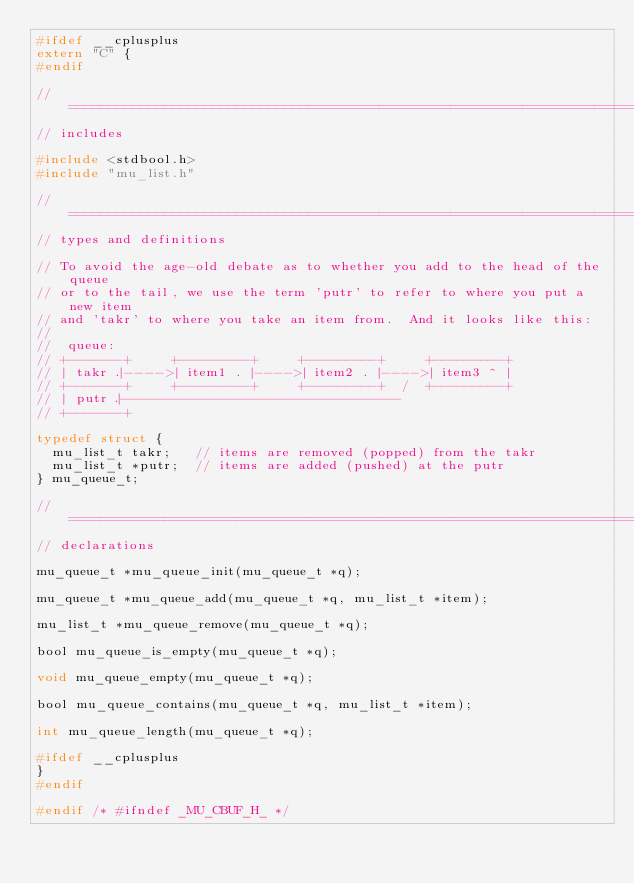Convert code to text. <code><loc_0><loc_0><loc_500><loc_500><_C_>#ifdef __cplusplus
extern "C" {
#endif

// =============================================================================
// includes

#include <stdbool.h>
#include "mu_list.h"

// =============================================================================
// types and definitions

// To avoid the age-old debate as to whether you add to the head of the queue
// or to the tail, we use the term 'putr' to refer to where you put a new item
// and 'takr' to where you take an item from.  And it looks like this:
//
//  queue:
// +-------+     +---------+     +---------+     +---------+
// | takr .|---->| item1 . |---->| item2 . |---->| item3 ^ |
// +-------+     +---------+     +---------+  /  +---------+
// | putr .|----------------------------------
// +-------+

typedef struct {
  mu_list_t takr;   // items are removed (popped) from the takr
  mu_list_t *putr;  // items are added (pushed) at the putr
} mu_queue_t;

// =============================================================================
// declarations

mu_queue_t *mu_queue_init(mu_queue_t *q);

mu_queue_t *mu_queue_add(mu_queue_t *q, mu_list_t *item);

mu_list_t *mu_queue_remove(mu_queue_t *q);

bool mu_queue_is_empty(mu_queue_t *q);

void mu_queue_empty(mu_queue_t *q);

bool mu_queue_contains(mu_queue_t *q, mu_list_t *item);

int mu_queue_length(mu_queue_t *q);

#ifdef __cplusplus
}
#endif

#endif /* #ifndef _MU_CBUF_H_ */
</code> 